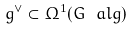Convert formula to latex. <formula><loc_0><loc_0><loc_500><loc_500>\ g ^ { \vee } \subset \Omega ^ { 1 } ( G ^ { \ } a l g )</formula> 